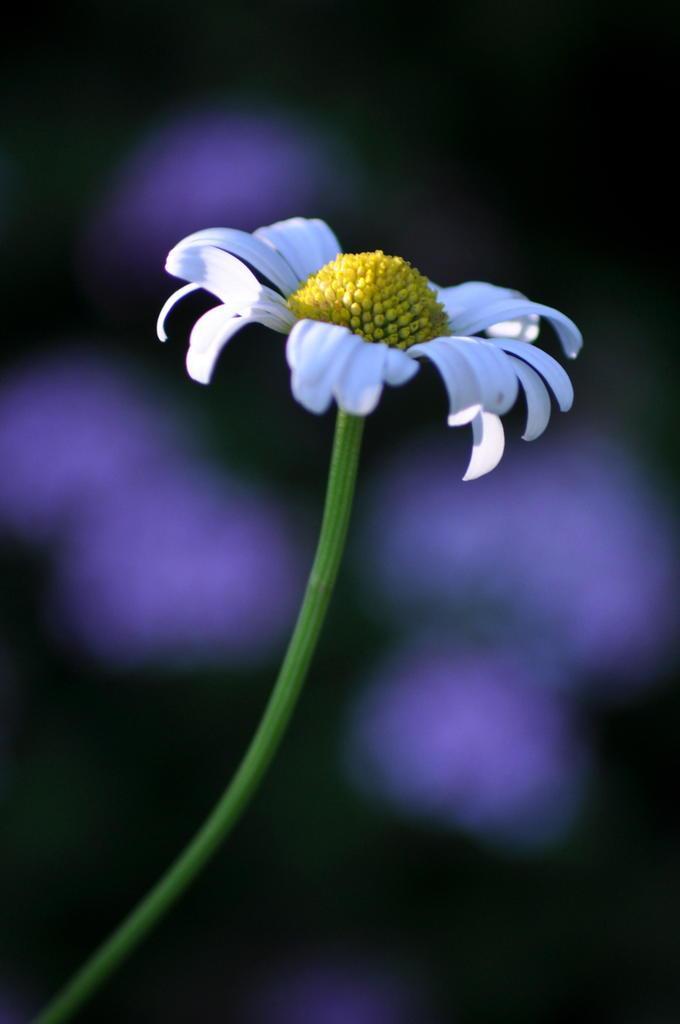How would you summarize this image in a sentence or two? In this image I see a flower which is of white and yellow in color and it is on the green color stem and it is blurred in the background. 